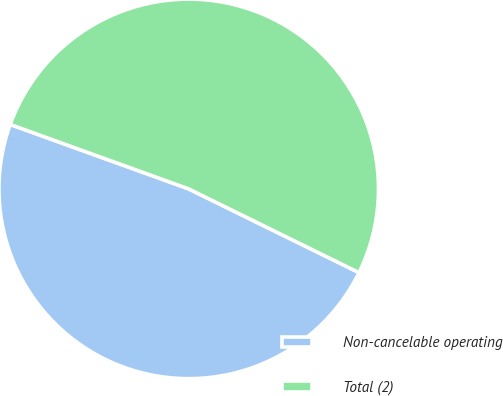Convert chart. <chart><loc_0><loc_0><loc_500><loc_500><pie_chart><fcel>Non-cancelable operating<fcel>Total (2)<nl><fcel>48.24%<fcel>51.76%<nl></chart> 